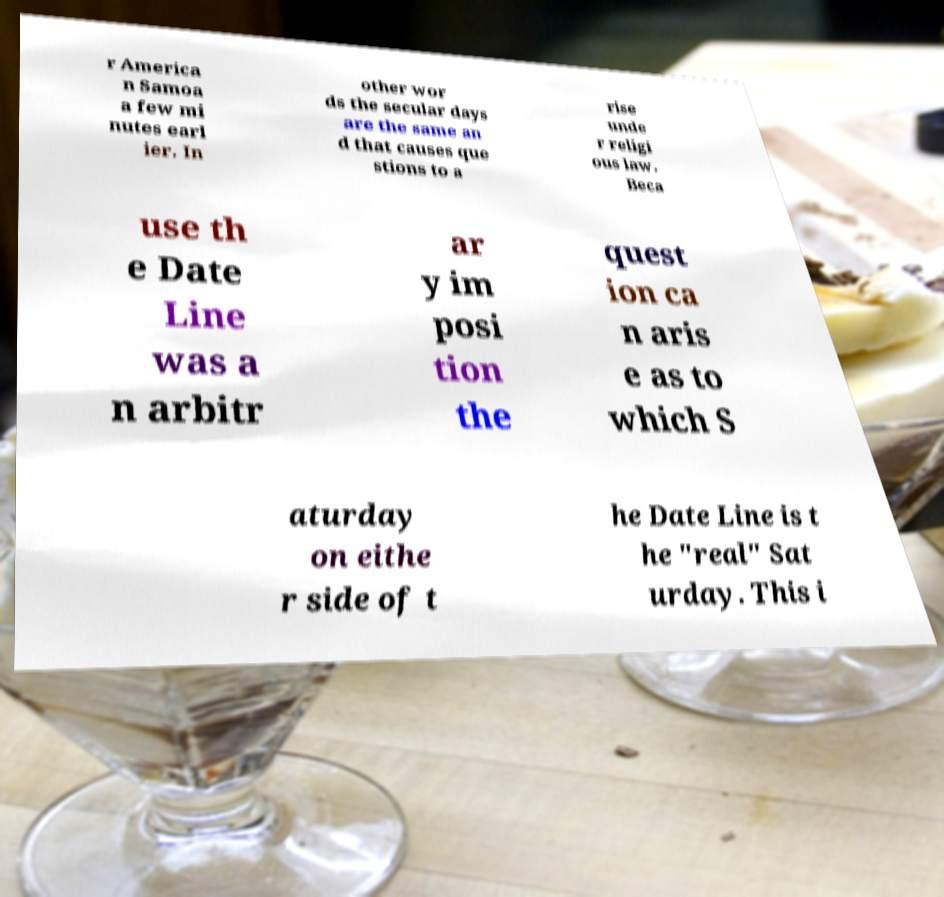For documentation purposes, I need the text within this image transcribed. Could you provide that? r America n Samoa a few mi nutes earl ier. In other wor ds the secular days are the same an d that causes que stions to a rise unde r religi ous law. Beca use th e Date Line was a n arbitr ar y im posi tion the quest ion ca n aris e as to which S aturday on eithe r side of t he Date Line is t he "real" Sat urday. This i 